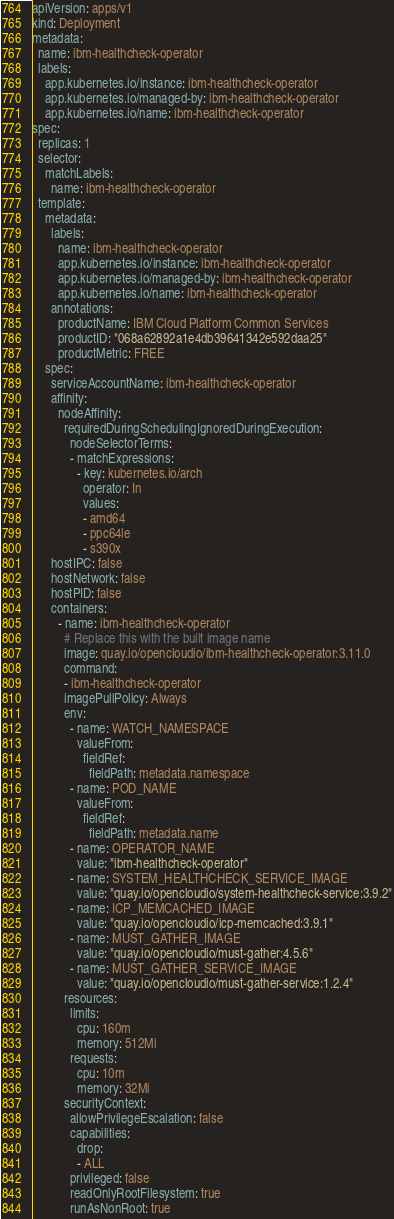<code> <loc_0><loc_0><loc_500><loc_500><_YAML_>apiVersion: apps/v1
kind: Deployment
metadata:
  name: ibm-healthcheck-operator
  labels:
    app.kubernetes.io/instance: ibm-healthcheck-operator
    app.kubernetes.io/managed-by: ibm-healthcheck-operator
    app.kubernetes.io/name: ibm-healthcheck-operator
spec:
  replicas: 1
  selector:
    matchLabels:
      name: ibm-healthcheck-operator
  template:
    metadata:
      labels:
        name: ibm-healthcheck-operator
        app.kubernetes.io/instance: ibm-healthcheck-operator
        app.kubernetes.io/managed-by: ibm-healthcheck-operator
        app.kubernetes.io/name: ibm-healthcheck-operator
      annotations:
        productName: IBM Cloud Platform Common Services
        productID: "068a62892a1e4db39641342e592daa25"
        productMetric: FREE
    spec:
      serviceAccountName: ibm-healthcheck-operator
      affinity:
        nodeAffinity:
          requiredDuringSchedulingIgnoredDuringExecution:
            nodeSelectorTerms:
            - matchExpressions:
              - key: kubernetes.io/arch
                operator: In
                values:
                - amd64
                - ppc64le
                - s390x
      hostIPC: false
      hostNetwork: false
      hostPID: false
      containers:
        - name: ibm-healthcheck-operator
          # Replace this with the built image name
          image: quay.io/opencloudio/ibm-healthcheck-operator:3.11.0
          command:
          - ibm-healthcheck-operator
          imagePullPolicy: Always
          env:
            - name: WATCH_NAMESPACE
              valueFrom:
                fieldRef:
                  fieldPath: metadata.namespace
            - name: POD_NAME
              valueFrom:
                fieldRef:
                  fieldPath: metadata.name
            - name: OPERATOR_NAME
              value: "ibm-healthcheck-operator"
            - name: SYSTEM_HEALTHCHECK_SERVICE_IMAGE
              value: "quay.io/opencloudio/system-healthcheck-service:3.9.2"
            - name: ICP_MEMCACHED_IMAGE
              value: "quay.io/opencloudio/icp-memcached:3.9.1"
            - name: MUST_GATHER_IMAGE
              value: "quay.io/opencloudio/must-gather:4.5.6"
            - name: MUST_GATHER_SERVICE_IMAGE
              value: "quay.io/opencloudio/must-gather-service:1.2.4"
          resources:
            limits:
              cpu: 160m
              memory: 512Mi
            requests:
              cpu: 10m
              memory: 32Mi
          securityContext:
            allowPrivilegeEscalation: false
            capabilities:
              drop:
              - ALL
            privileged: false
            readOnlyRootFilesystem: true
            runAsNonRoot: true
</code> 